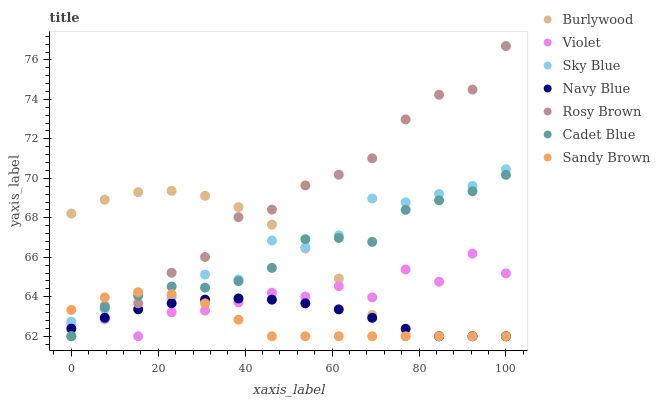Does Sandy Brown have the minimum area under the curve?
Answer yes or no. Yes. Does Rosy Brown have the maximum area under the curve?
Answer yes or no. Yes. Does Burlywood have the minimum area under the curve?
Answer yes or no. No. Does Burlywood have the maximum area under the curve?
Answer yes or no. No. Is Navy Blue the smoothest?
Answer yes or no. Yes. Is Violet the roughest?
Answer yes or no. Yes. Is Burlywood the smoothest?
Answer yes or no. No. Is Burlywood the roughest?
Answer yes or no. No. Does Cadet Blue have the lowest value?
Answer yes or no. Yes. Does Sky Blue have the lowest value?
Answer yes or no. No. Does Rosy Brown have the highest value?
Answer yes or no. Yes. Does Burlywood have the highest value?
Answer yes or no. No. Is Navy Blue less than Sky Blue?
Answer yes or no. Yes. Is Sky Blue greater than Navy Blue?
Answer yes or no. Yes. Does Rosy Brown intersect Sky Blue?
Answer yes or no. Yes. Is Rosy Brown less than Sky Blue?
Answer yes or no. No. Is Rosy Brown greater than Sky Blue?
Answer yes or no. No. Does Navy Blue intersect Sky Blue?
Answer yes or no. No. 